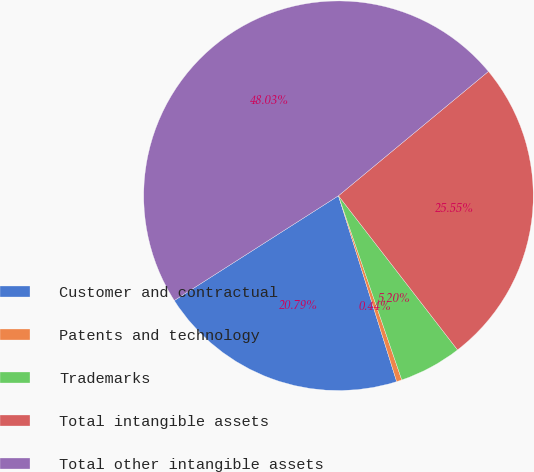<chart> <loc_0><loc_0><loc_500><loc_500><pie_chart><fcel>Customer and contractual<fcel>Patents and technology<fcel>Trademarks<fcel>Total intangible assets<fcel>Total other intangible assets<nl><fcel>20.79%<fcel>0.44%<fcel>5.2%<fcel>25.55%<fcel>48.03%<nl></chart> 